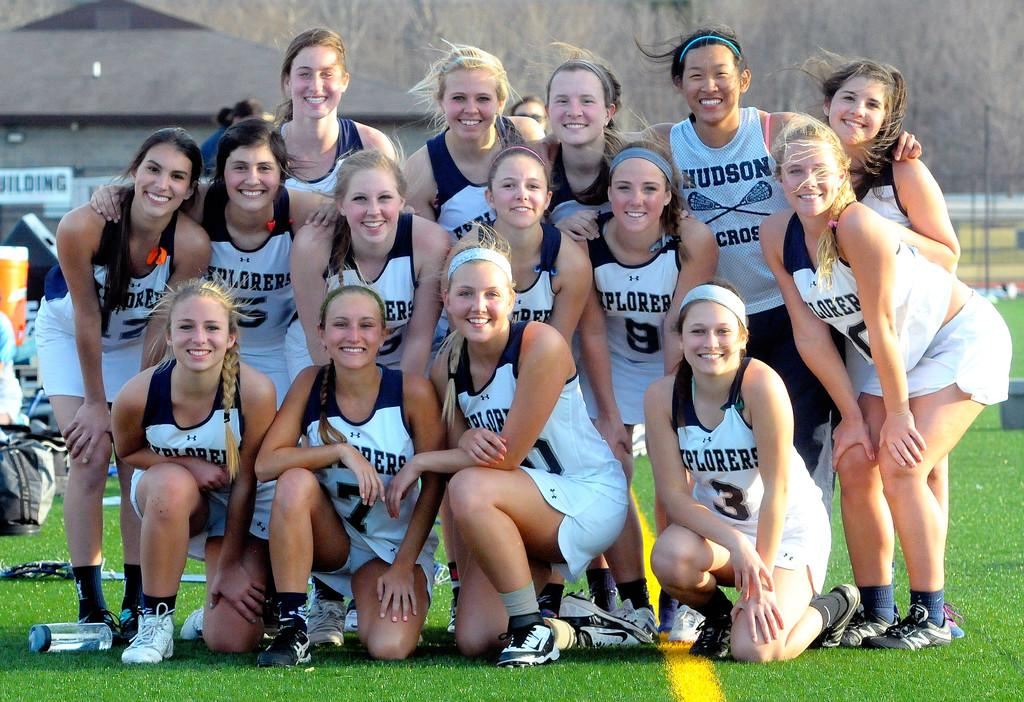<image>
Give a short and clear explanation of the subsequent image. The person on the bottom right is wearing number 3 